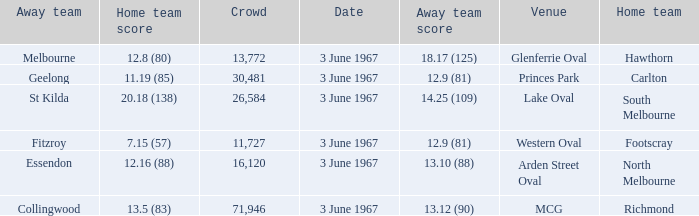Where did Geelong play as the away team? Princes Park. 